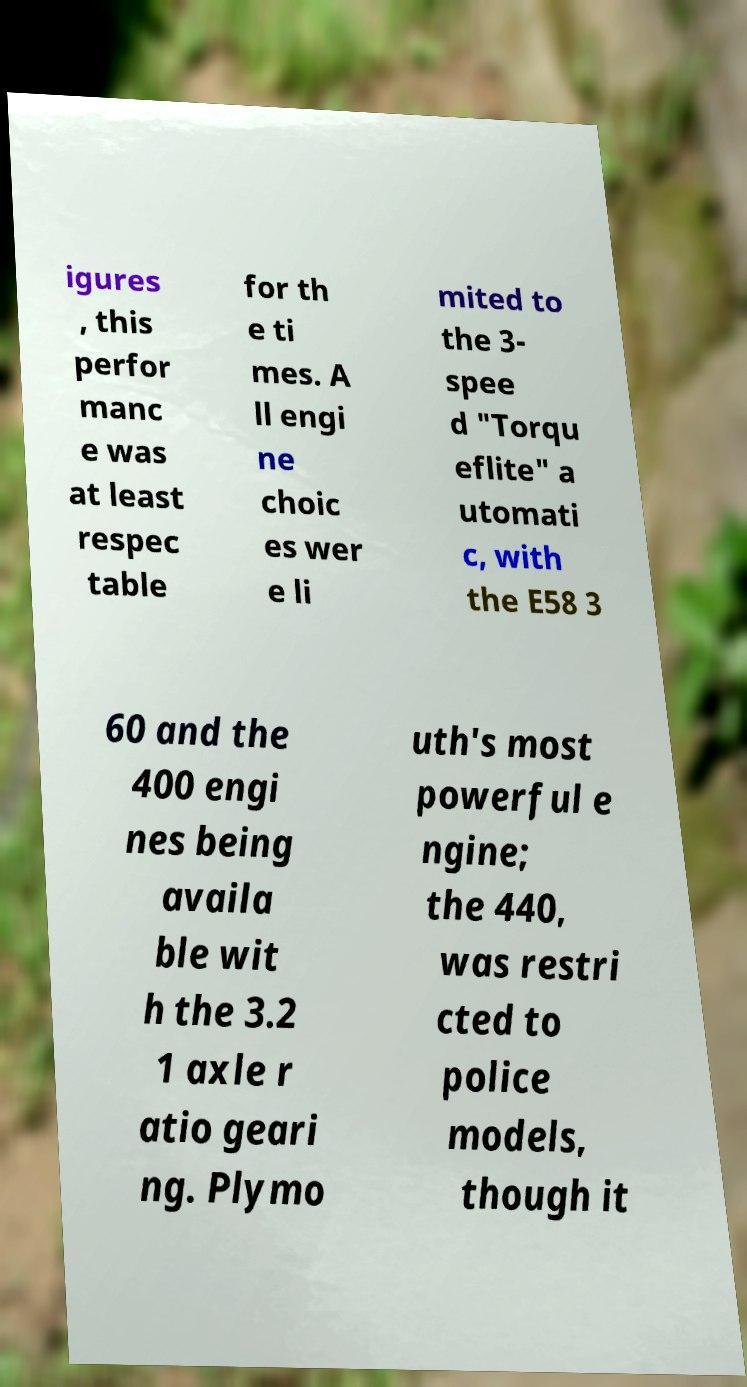For documentation purposes, I need the text within this image transcribed. Could you provide that? igures , this perfor manc e was at least respec table for th e ti mes. A ll engi ne choic es wer e li mited to the 3- spee d "Torqu eflite" a utomati c, with the E58 3 60 and the 400 engi nes being availa ble wit h the 3.2 1 axle r atio geari ng. Plymo uth's most powerful e ngine; the 440, was restri cted to police models, though it 